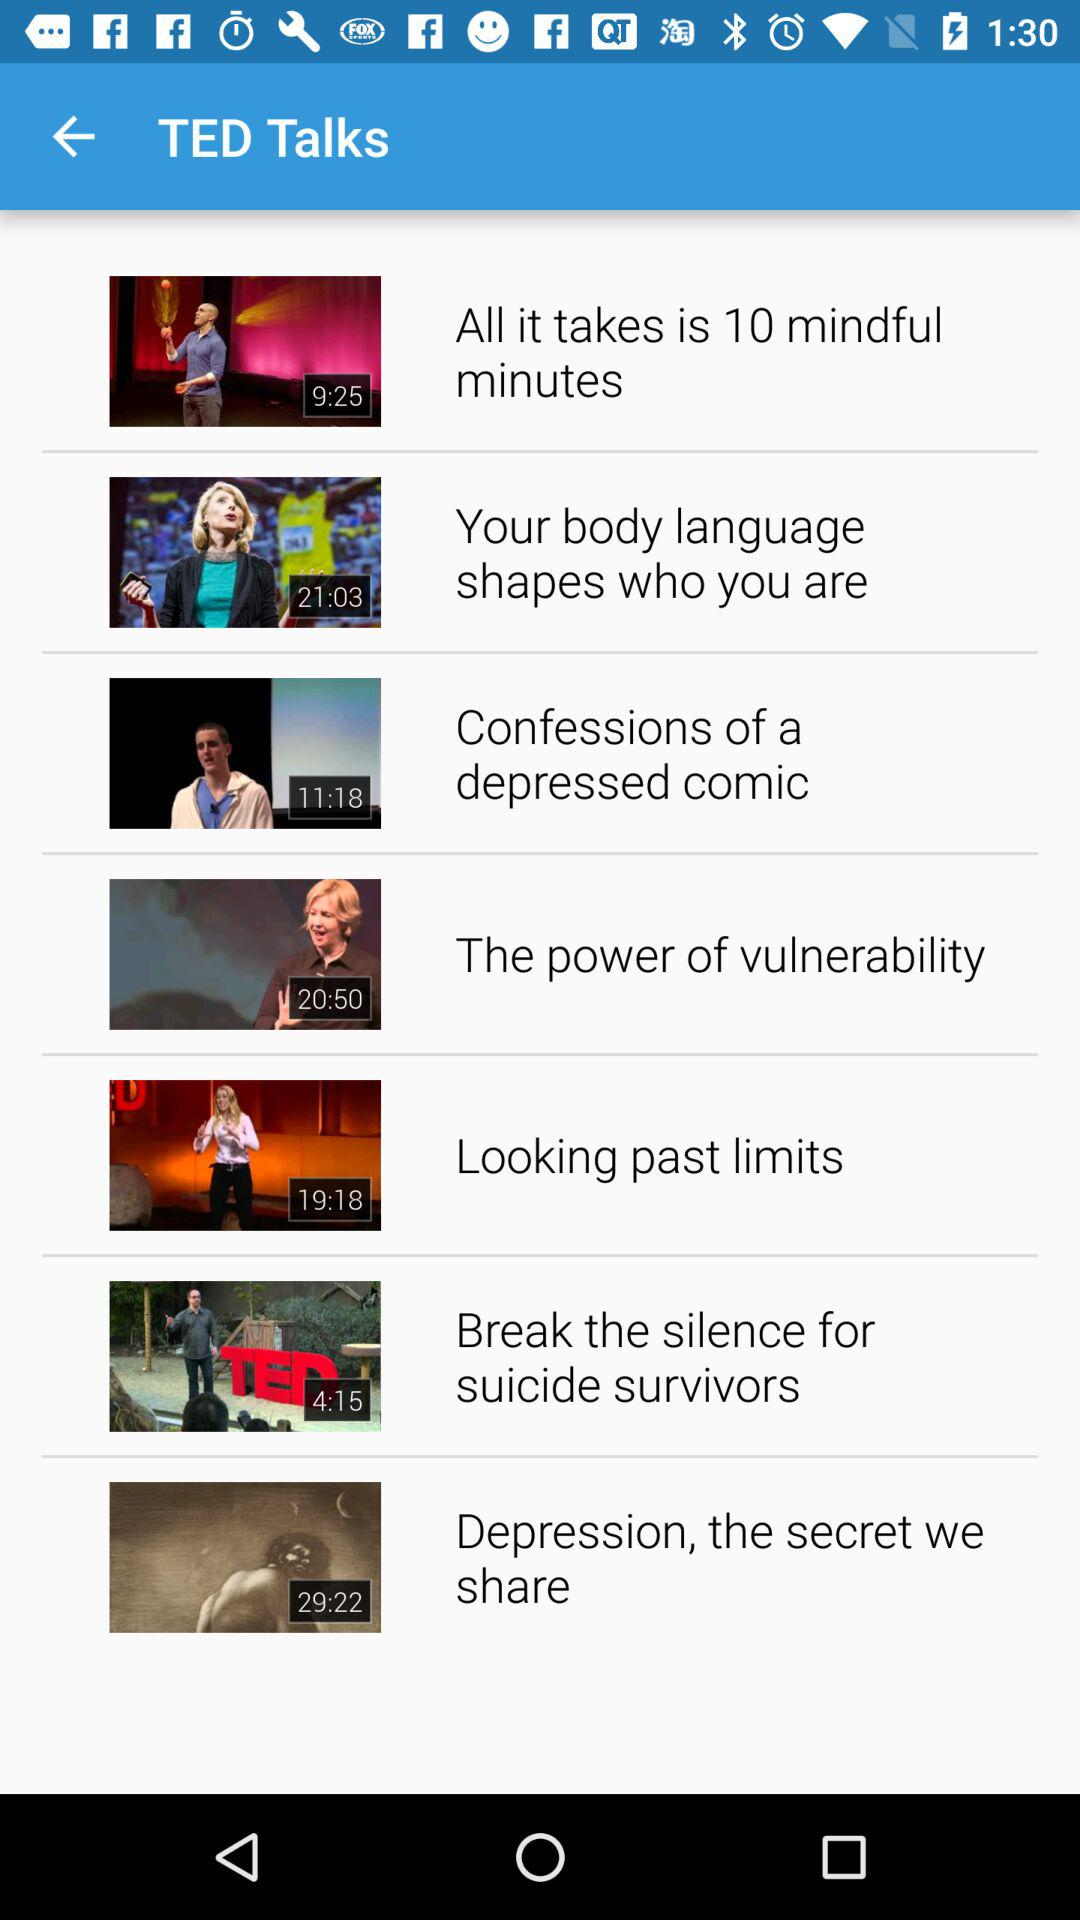How many videos are there in total?
Answer the question using a single word or phrase. 7 